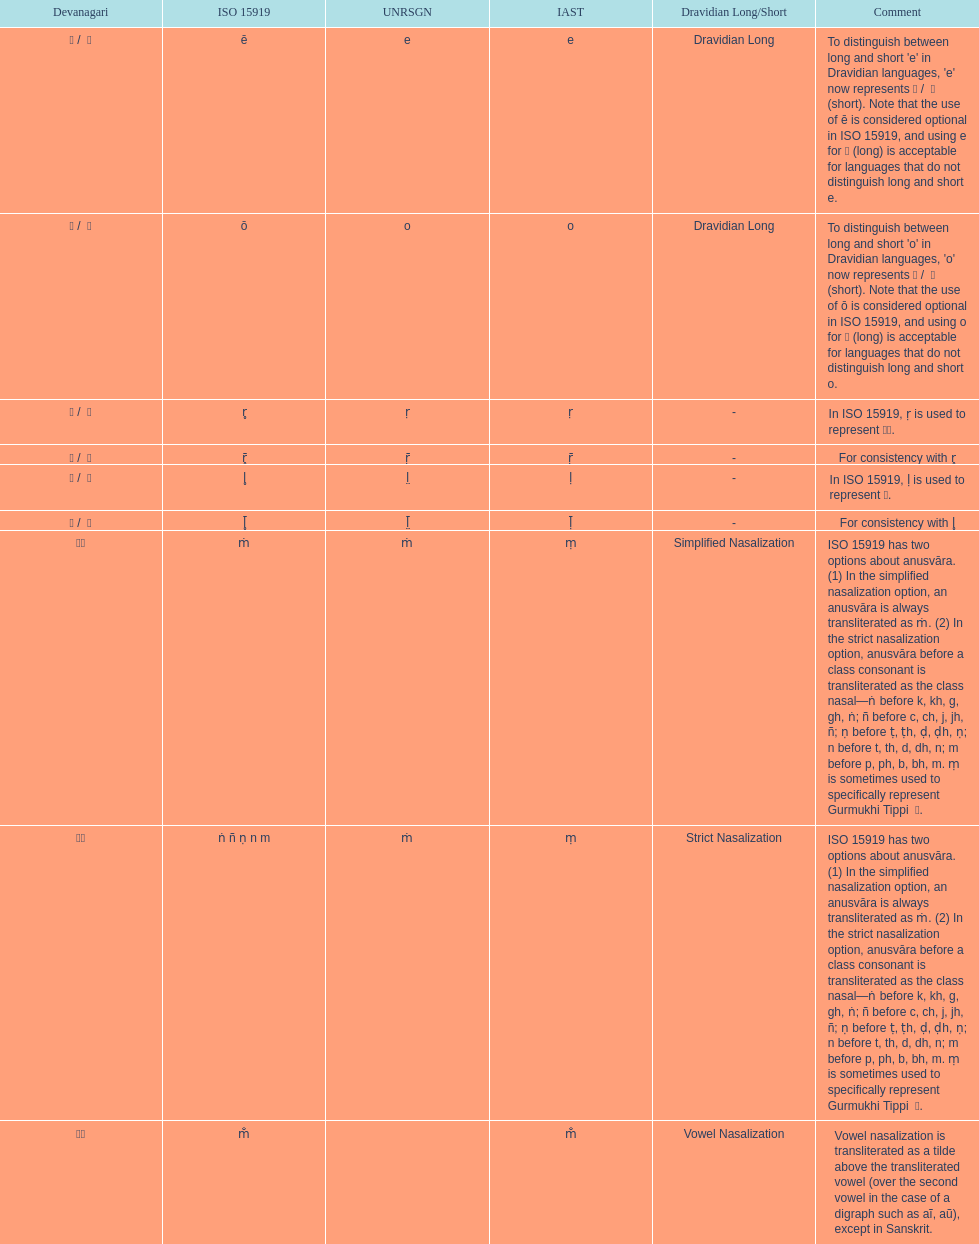Which devanagaria means the same as this iast letter: o? ओ / ो. 